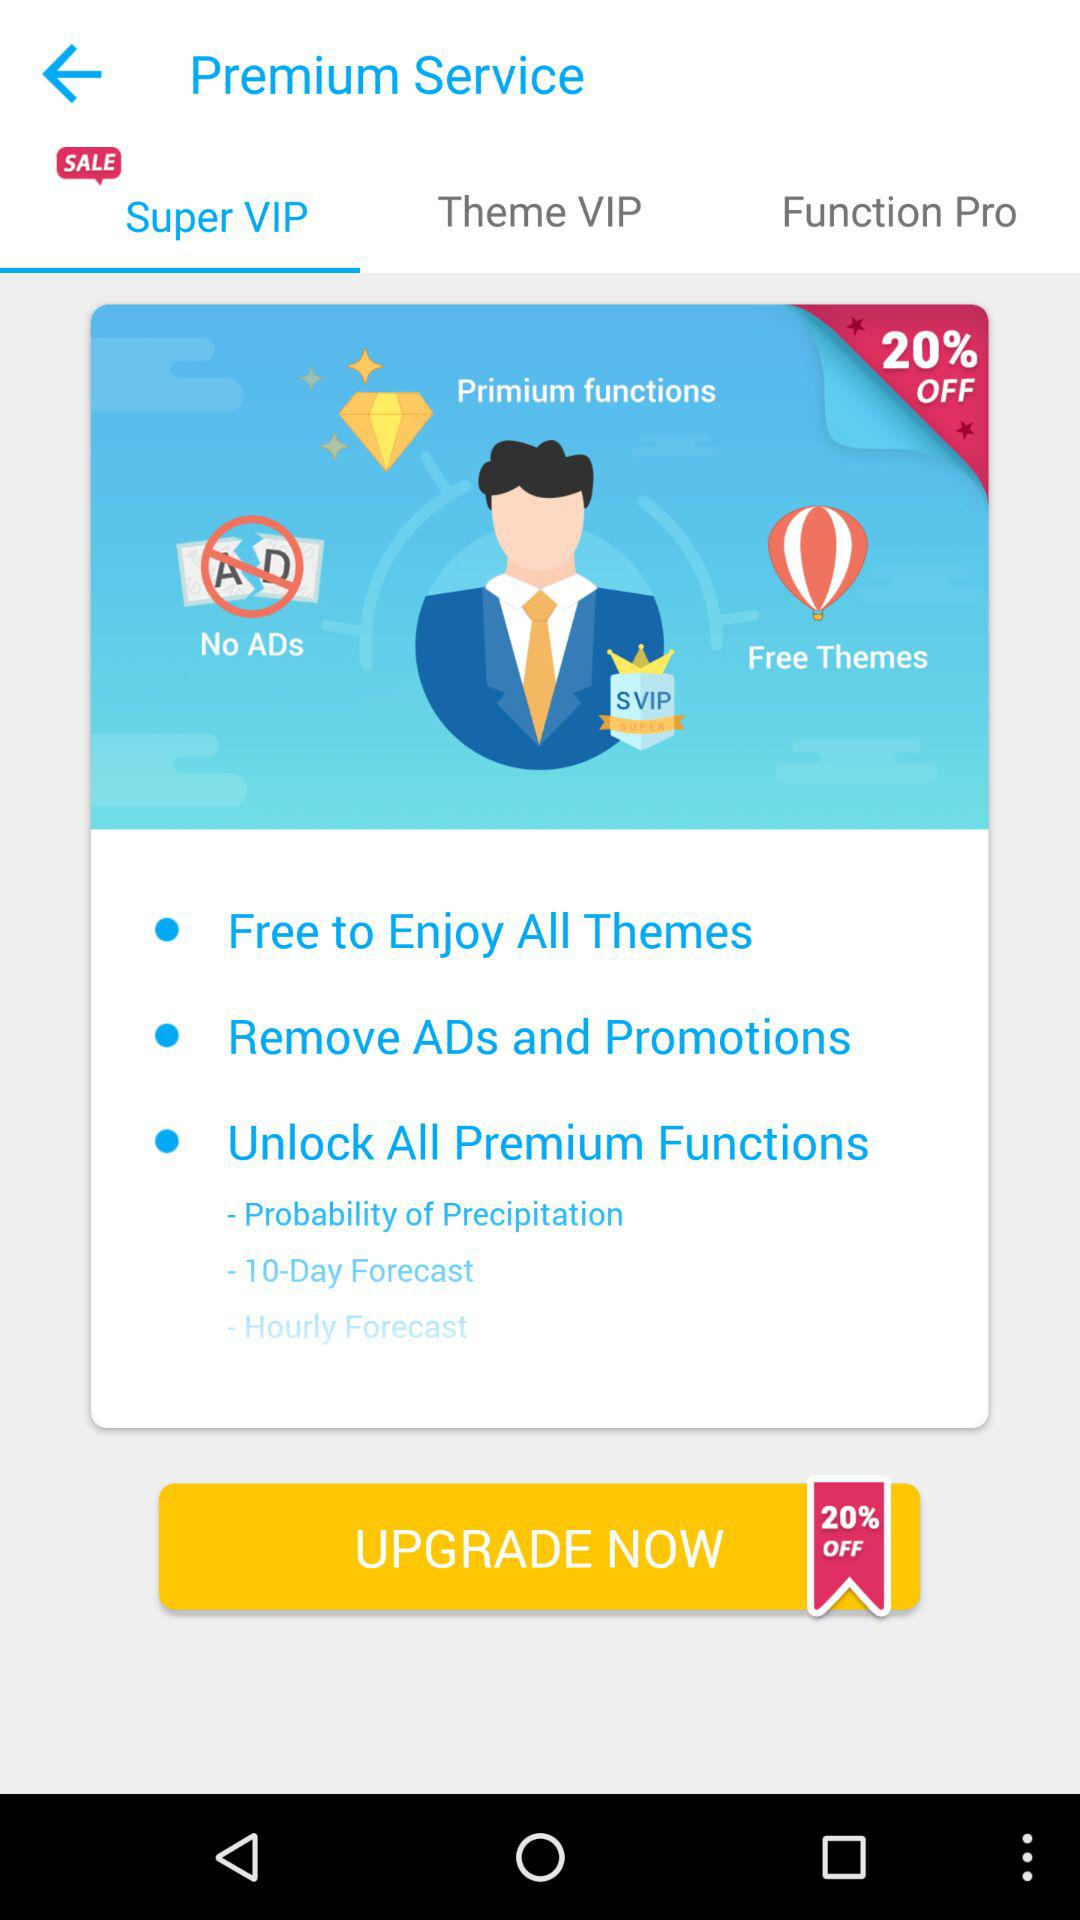How many percent off is the upgrade offer?
Answer the question using a single word or phrase. 20% 